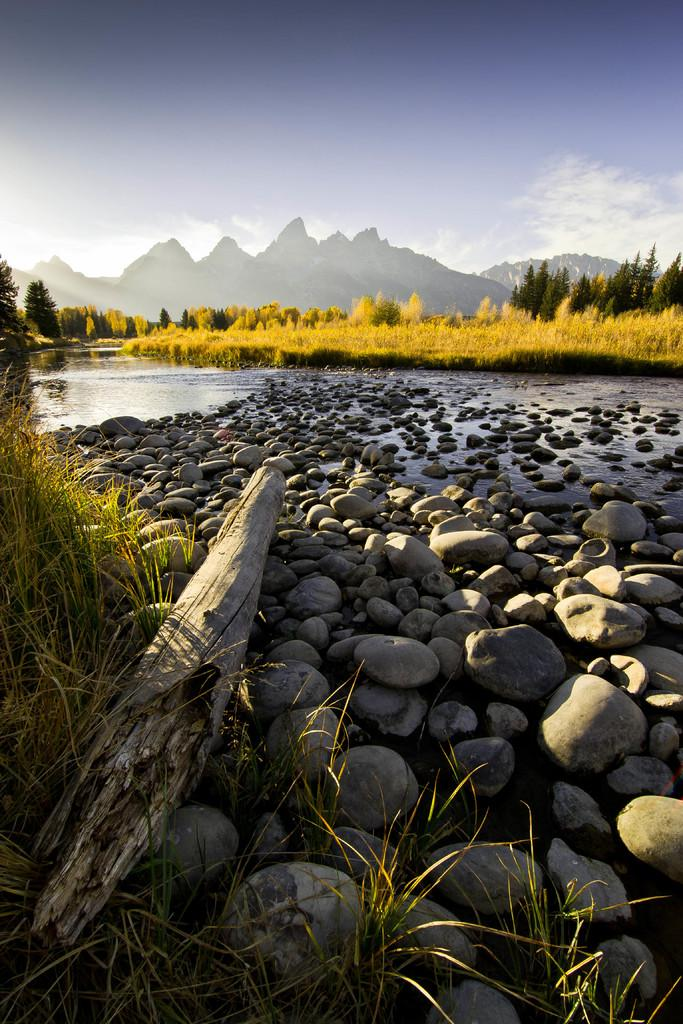What type of natural elements can be seen in the image? There are stones, water, grass, trees, and hills visible in the image. What is the condition of the water in the image? The water is present in the image, but its condition (e.g., calm, flowing) cannot be determined from the provided facts. What type of vegetation is present in the image? There are trees and grass visible in the image. What is visible in the background of the image? The sky is visible in the background of the image. What type of bun is being used for the operation in the image? There is no mention of a bun or an operation in the image; it features natural elements such as stones, water, grass, trees, hills, and the sky. 